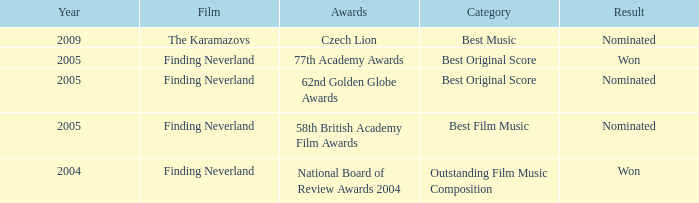What was the result for years prior to 2005? Won. 